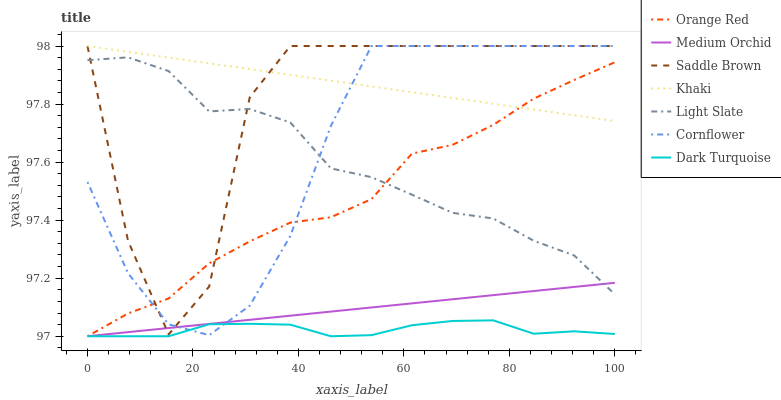Does Dark Turquoise have the minimum area under the curve?
Answer yes or no. Yes. Does Khaki have the maximum area under the curve?
Answer yes or no. Yes. Does Light Slate have the minimum area under the curve?
Answer yes or no. No. Does Light Slate have the maximum area under the curve?
Answer yes or no. No. Is Medium Orchid the smoothest?
Answer yes or no. Yes. Is Saddle Brown the roughest?
Answer yes or no. Yes. Is Khaki the smoothest?
Answer yes or no. No. Is Khaki the roughest?
Answer yes or no. No. Does Dark Turquoise have the lowest value?
Answer yes or no. Yes. Does Light Slate have the lowest value?
Answer yes or no. No. Does Saddle Brown have the highest value?
Answer yes or no. Yes. Does Light Slate have the highest value?
Answer yes or no. No. Is Light Slate less than Khaki?
Answer yes or no. Yes. Is Khaki greater than Light Slate?
Answer yes or no. Yes. Does Khaki intersect Cornflower?
Answer yes or no. Yes. Is Khaki less than Cornflower?
Answer yes or no. No. Is Khaki greater than Cornflower?
Answer yes or no. No. Does Light Slate intersect Khaki?
Answer yes or no. No. 